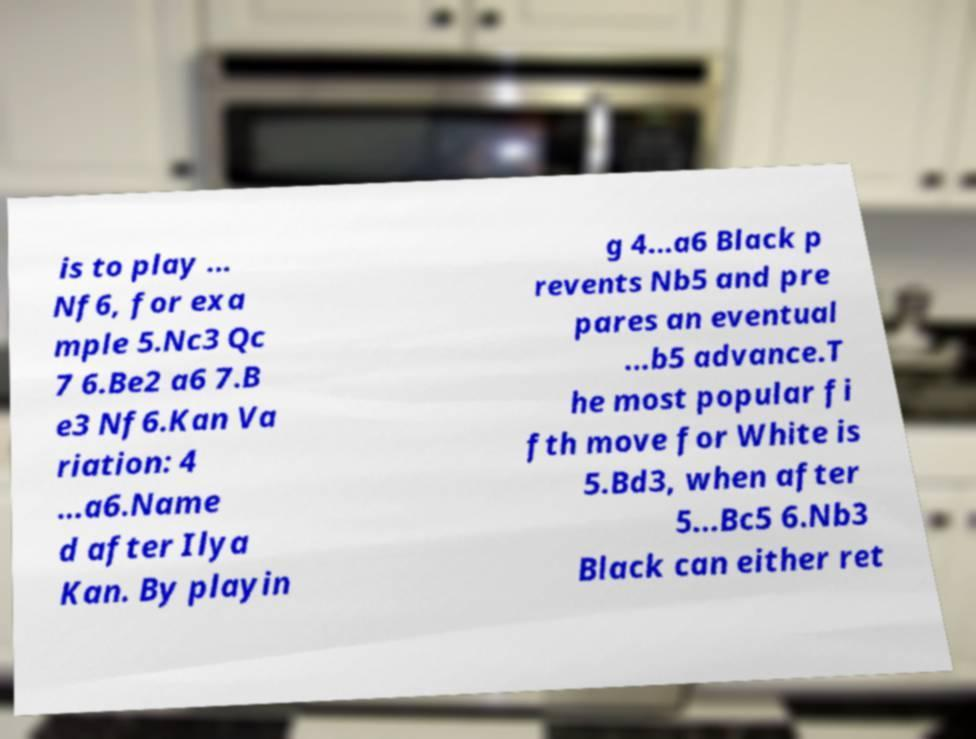I need the written content from this picture converted into text. Can you do that? is to play ... Nf6, for exa mple 5.Nc3 Qc 7 6.Be2 a6 7.B e3 Nf6.Kan Va riation: 4 ...a6.Name d after Ilya Kan. By playin g 4...a6 Black p revents Nb5 and pre pares an eventual ...b5 advance.T he most popular fi fth move for White is 5.Bd3, when after 5...Bc5 6.Nb3 Black can either ret 